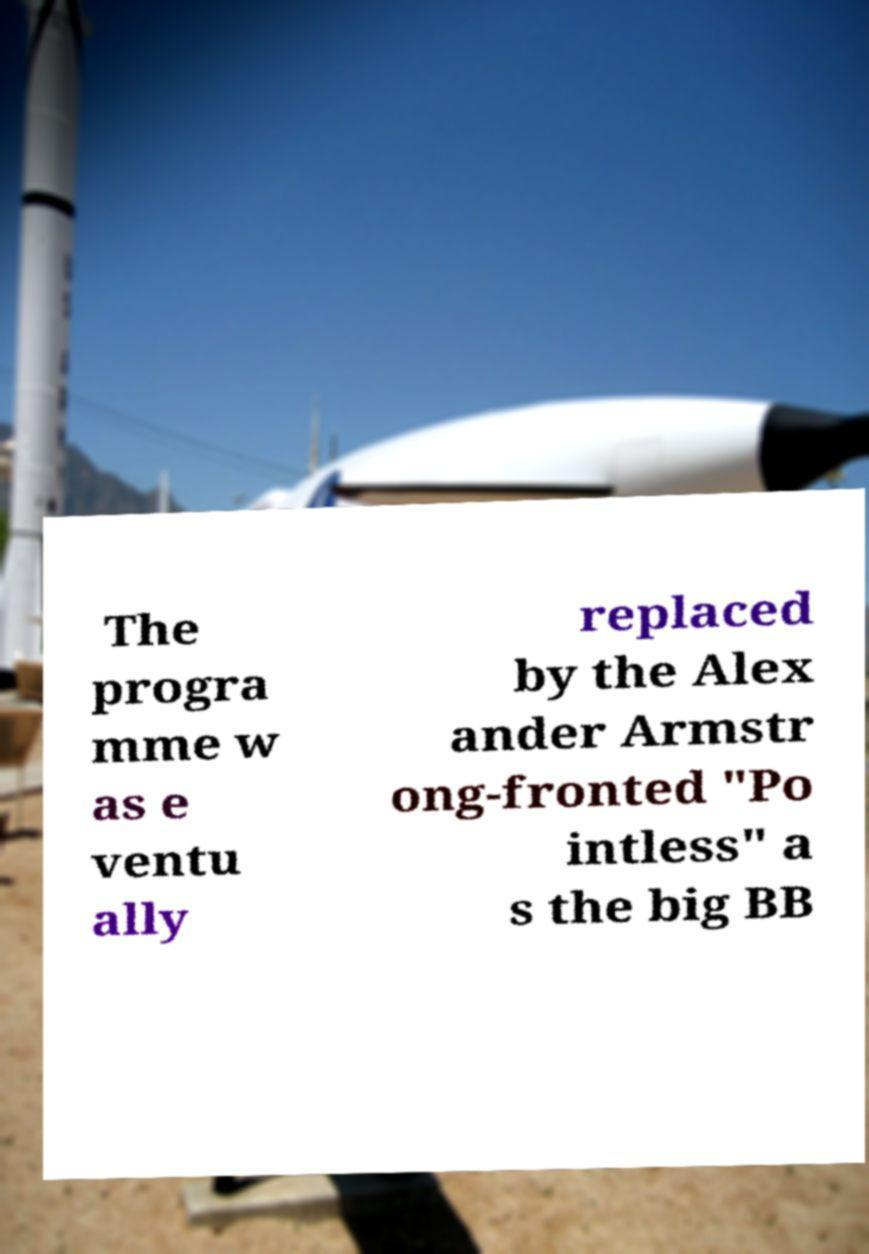Can you accurately transcribe the text from the provided image for me? The progra mme w as e ventu ally replaced by the Alex ander Armstr ong-fronted "Po intless" a s the big BB 